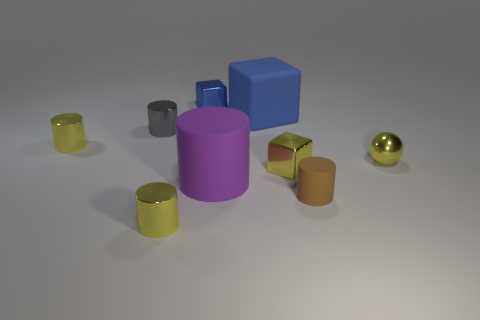Subtract all yellow cylinders. How many were subtracted if there are1yellow cylinders left? 1 Subtract all gray spheres. How many blue cubes are left? 2 Subtract all gray cylinders. How many cylinders are left? 4 Subtract all gray metallic cylinders. How many cylinders are left? 4 Subtract all green cylinders. Subtract all brown spheres. How many cylinders are left? 5 Subtract all cylinders. How many objects are left? 4 Subtract all yellow blocks. Subtract all tiny yellow shiny cylinders. How many objects are left? 6 Add 6 small gray cylinders. How many small gray cylinders are left? 7 Add 8 small rubber cylinders. How many small rubber cylinders exist? 9 Subtract 0 brown cubes. How many objects are left? 9 